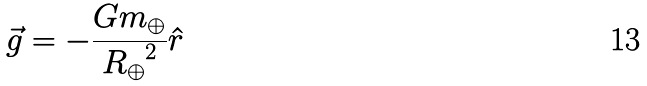Convert formula to latex. <formula><loc_0><loc_0><loc_500><loc_500>\vec { g } = - \frac { G m _ { \oplus } } { { R _ { \oplus } } ^ { 2 } } \hat { r }</formula> 